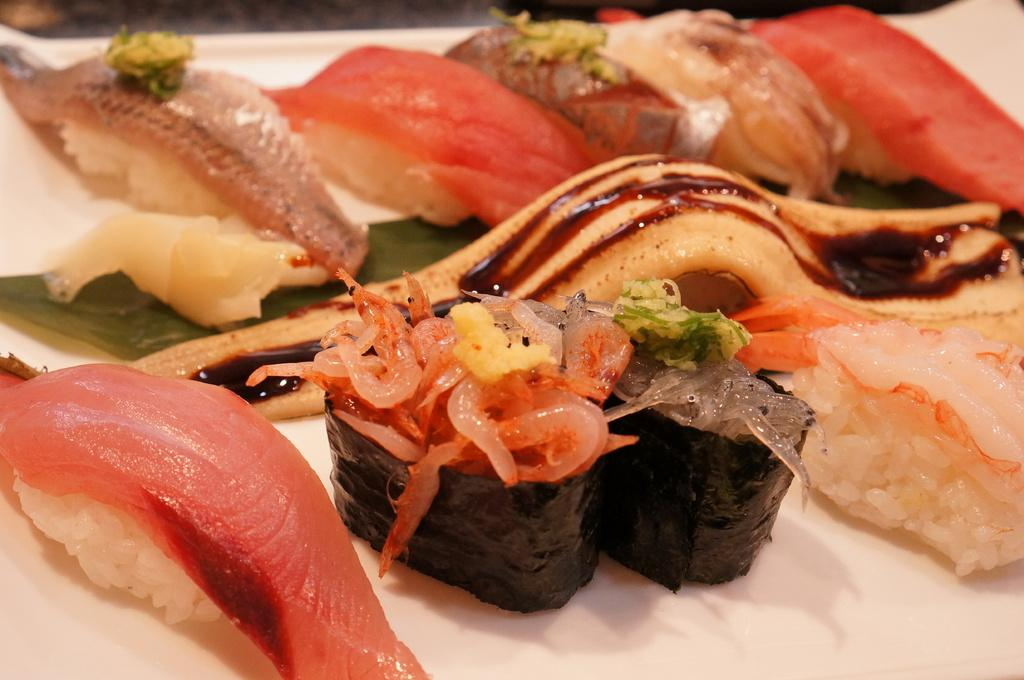What types of objects are present in the image? There are food items in the image. What is the color of the surface on which the food items are placed? The food items are on a white surface. What type of crime is being committed in the image? There is no crime present in the image; it features food items on a white surface. How many sisters can be seen in the image? There are no people, including sisters, present in the image. 